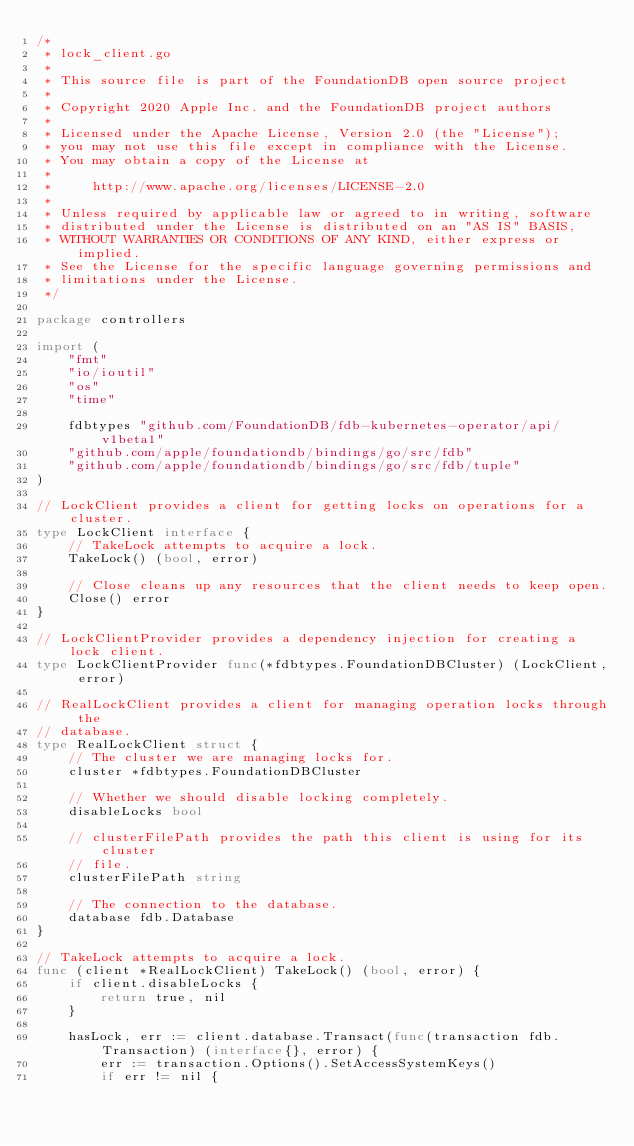Convert code to text. <code><loc_0><loc_0><loc_500><loc_500><_Go_>/*
 * lock_client.go
 *
 * This source file is part of the FoundationDB open source project
 *
 * Copyright 2020 Apple Inc. and the FoundationDB project authors
 *
 * Licensed under the Apache License, Version 2.0 (the "License");
 * you may not use this file except in compliance with the License.
 * You may obtain a copy of the License at
 *
 *     http://www.apache.org/licenses/LICENSE-2.0
 *
 * Unless required by applicable law or agreed to in writing, software
 * distributed under the License is distributed on an "AS IS" BASIS,
 * WITHOUT WARRANTIES OR CONDITIONS OF ANY KIND, either express or implied.
 * See the License for the specific language governing permissions and
 * limitations under the License.
 */

package controllers

import (
	"fmt"
	"io/ioutil"
	"os"
	"time"

	fdbtypes "github.com/FoundationDB/fdb-kubernetes-operator/api/v1beta1"
	"github.com/apple/foundationdb/bindings/go/src/fdb"
	"github.com/apple/foundationdb/bindings/go/src/fdb/tuple"
)

// LockClient provides a client for getting locks on operations for a cluster.
type LockClient interface {
	// TakeLock attempts to acquire a lock.
	TakeLock() (bool, error)

	// Close cleans up any resources that the client needs to keep open.
	Close() error
}

// LockClientProvider provides a dependency injection for creating a lock client.
type LockClientProvider func(*fdbtypes.FoundationDBCluster) (LockClient, error)

// RealLockClient provides a client for managing operation locks through the
// database.
type RealLockClient struct {
	// The cluster we are managing locks for.
	cluster *fdbtypes.FoundationDBCluster

	// Whether we should disable locking completely.
	disableLocks bool

	// clusterFilePath provides the path this client is using for its cluster
	// file.
	clusterFilePath string

	// The connection to the database.
	database fdb.Database
}

// TakeLock attempts to acquire a lock.
func (client *RealLockClient) TakeLock() (bool, error) {
	if client.disableLocks {
		return true, nil
	}

	hasLock, err := client.database.Transact(func(transaction fdb.Transaction) (interface{}, error) {
		err := transaction.Options().SetAccessSystemKeys()
		if err != nil {</code> 